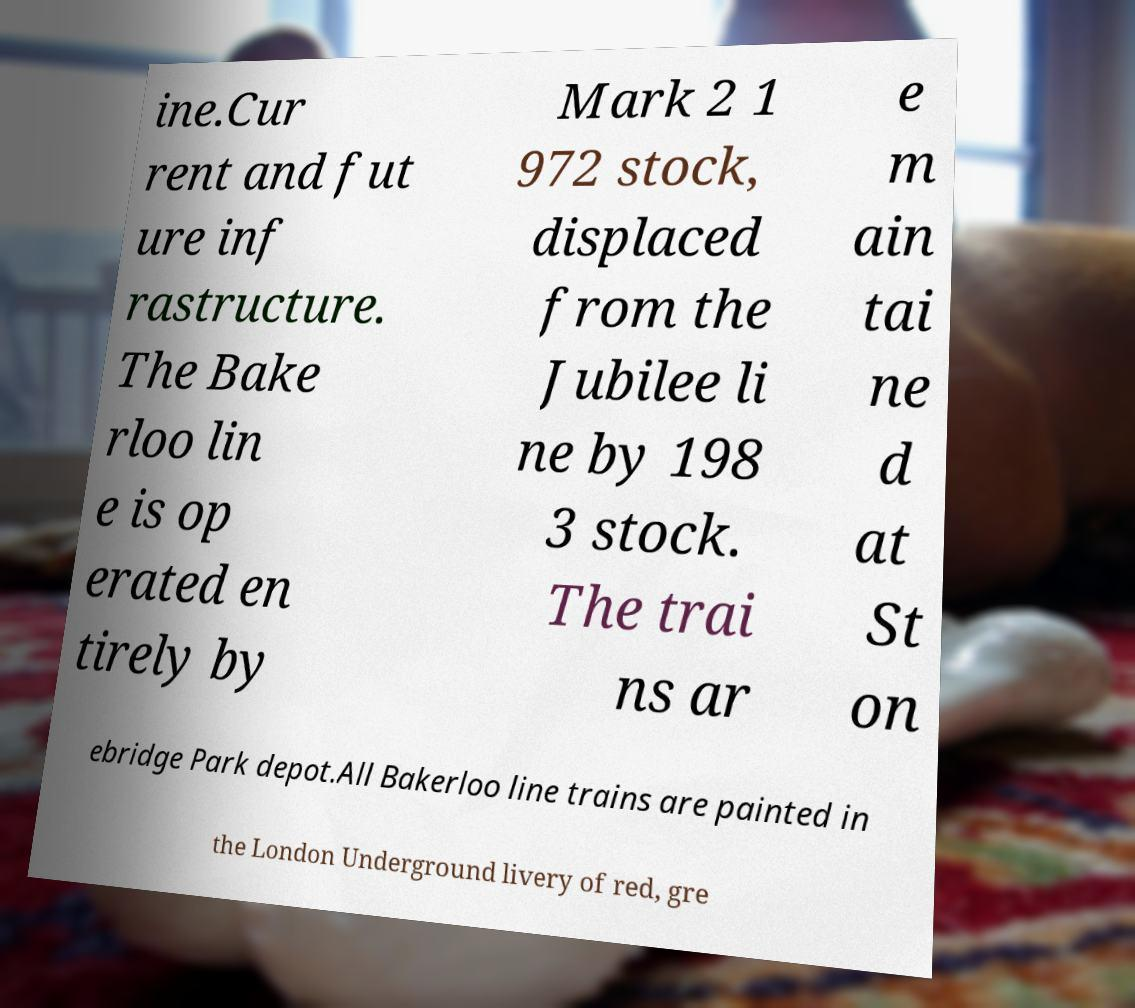Can you read and provide the text displayed in the image?This photo seems to have some interesting text. Can you extract and type it out for me? ine.Cur rent and fut ure inf rastructure. The Bake rloo lin e is op erated en tirely by Mark 2 1 972 stock, displaced from the Jubilee li ne by 198 3 stock. The trai ns ar e m ain tai ne d at St on ebridge Park depot.All Bakerloo line trains are painted in the London Underground livery of red, gre 